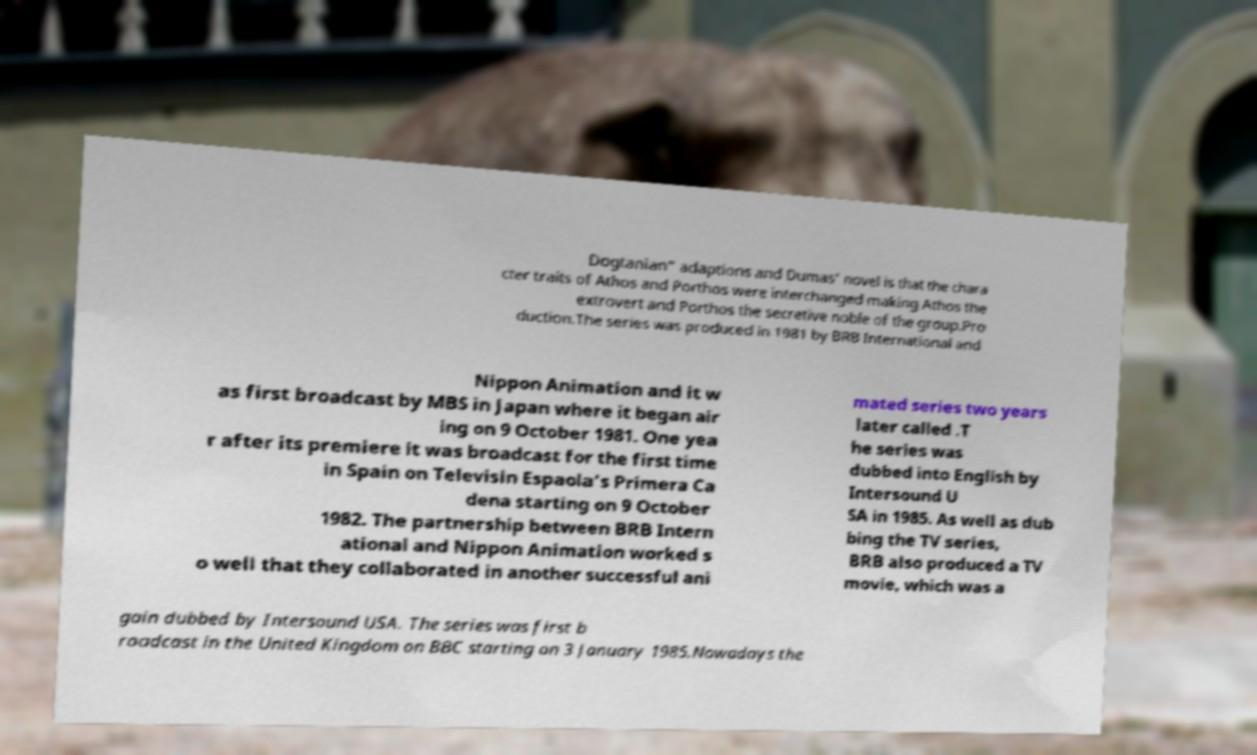Can you accurately transcribe the text from the provided image for me? Dogtanian" adaptions and Dumas' novel is that the chara cter traits of Athos and Porthos were interchanged making Athos the extrovert and Porthos the secretive noble of the group.Pro duction.The series was produced in 1981 by BRB International and Nippon Animation and it w as first broadcast by MBS in Japan where it began air ing on 9 October 1981. One yea r after its premiere it was broadcast for the first time in Spain on Televisin Espaola's Primera Ca dena starting on 9 October 1982. The partnership between BRB Intern ational and Nippon Animation worked s o well that they collaborated in another successful ani mated series two years later called .T he series was dubbed into English by Intersound U SA in 1985. As well as dub bing the TV series, BRB also produced a TV movie, which was a gain dubbed by Intersound USA. The series was first b roadcast in the United Kingdom on BBC starting on 3 January 1985.Nowadays the 